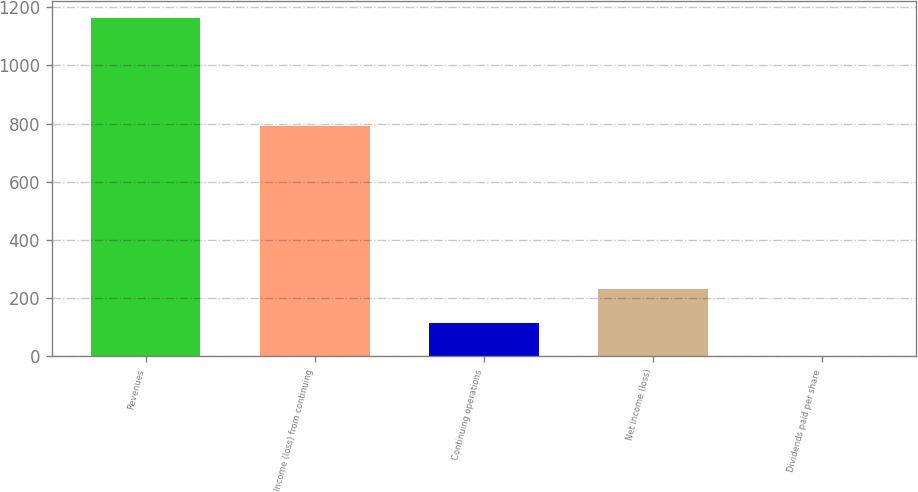Convert chart to OTSL. <chart><loc_0><loc_0><loc_500><loc_500><bar_chart><fcel>Revenues<fcel>Income (loss) from continuing<fcel>Continuing operations<fcel>Net income (loss)<fcel>Dividends paid per share<nl><fcel>1164<fcel>793<fcel>116.45<fcel>232.85<fcel>0.05<nl></chart> 